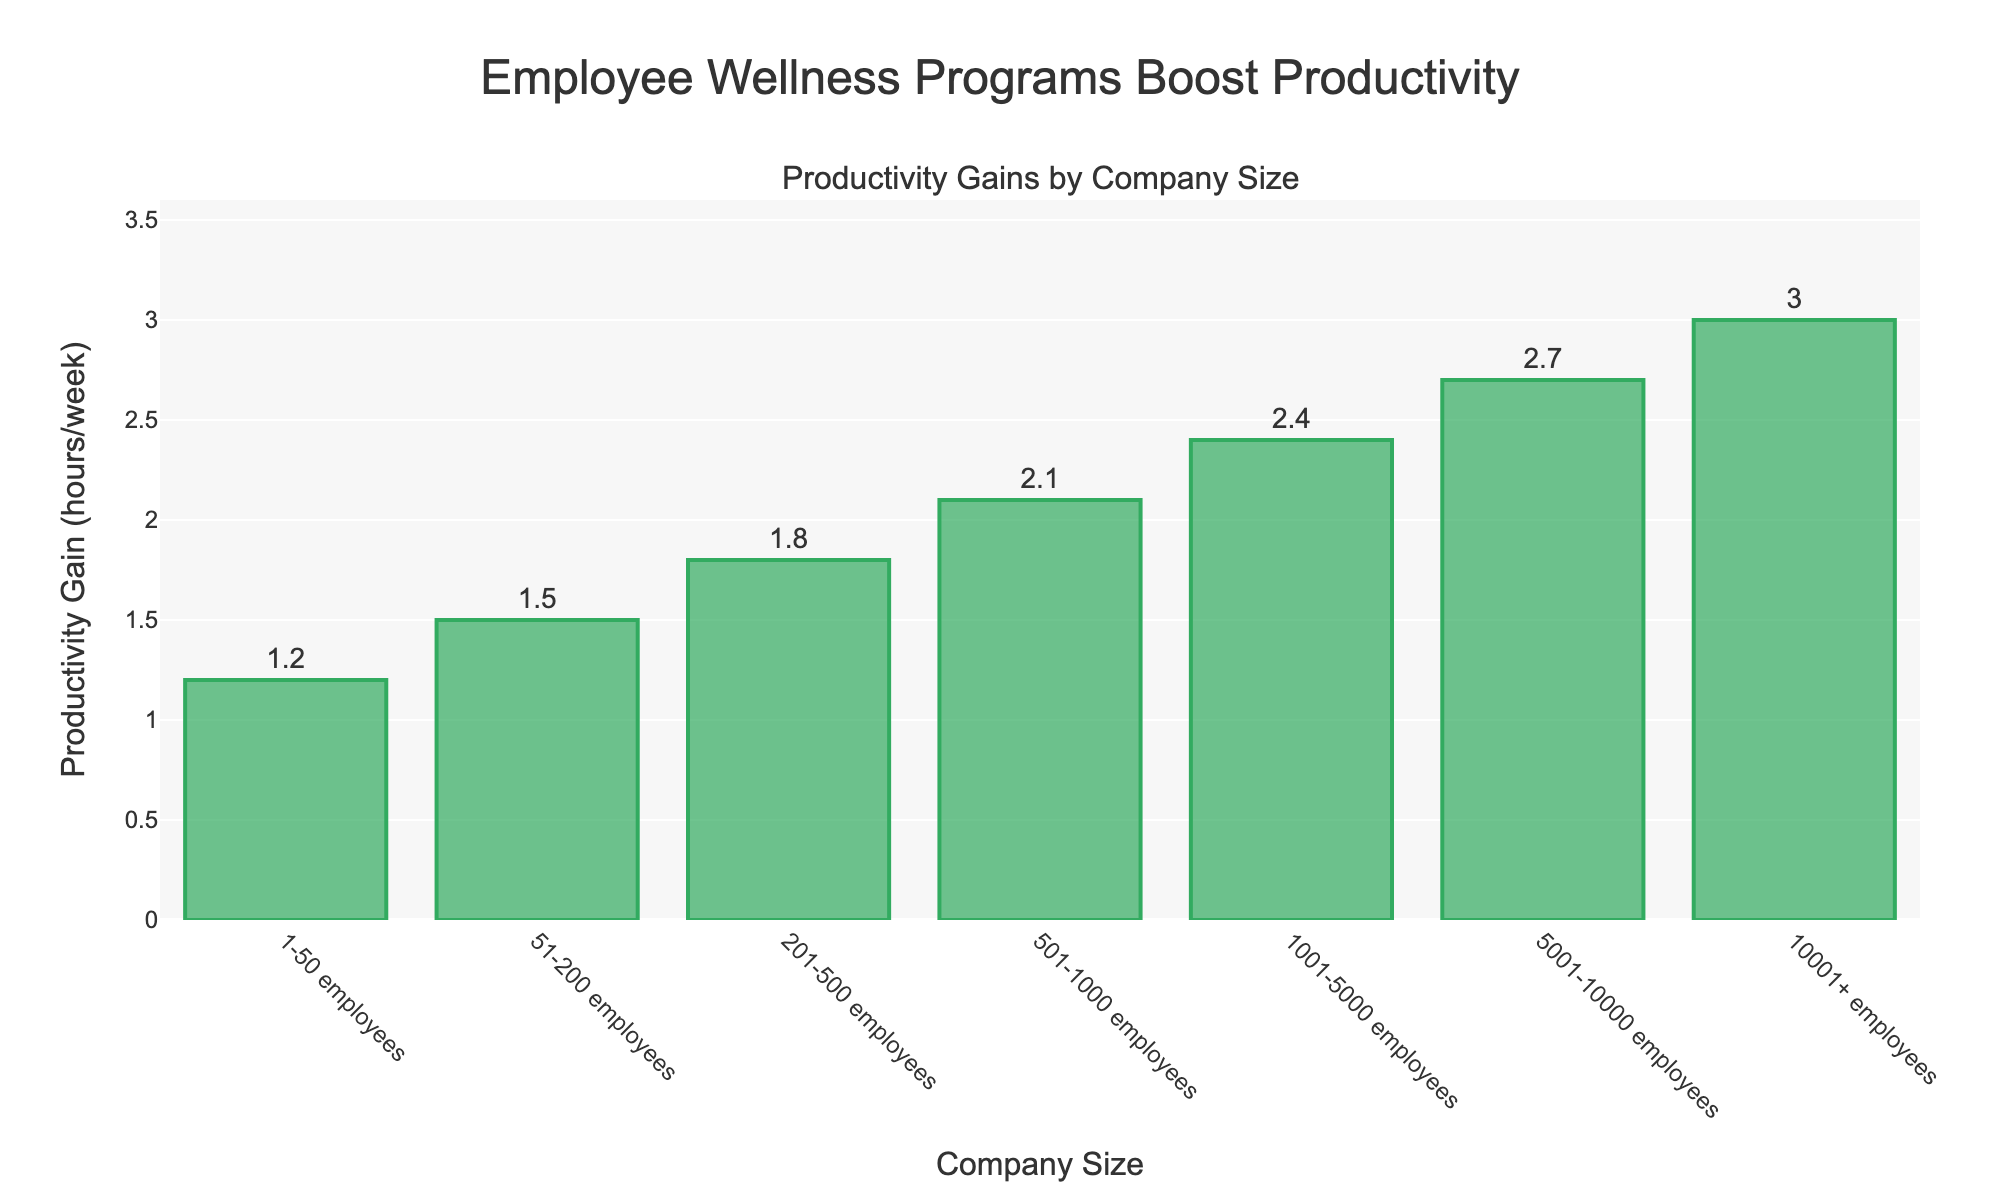What is the productivity gain for companies with 1-50 employees? The bar representing companies with 1-50 employees shows a productivity gain of 1.2 hours per week, indicated by the height of the bar and the text label atop it.
Answer: 1.2 How does the productivity gain for companies with 10001+ employees compare to that of companies with 1-50 employees? The bar for 10001+ employees reaches 3.0 hours per week, while the bar for 1-50 employees is at 1.2 hours per week. Subtracting 1.2 from 3.0 gives the difference.
Answer: 1.8 Which company size category sees the highest productivity gain from wellness programs? The bar for 10001+ employees is the tallest among the categories, reaching 3.0 hours per week.
Answer: 10001+ employees What is the total productivity gain for companies with 51-200 employees and 201-500 employees combined? Add the productivity gains for 51-200 employees (1.5 hours) and 201-500 employees (1.8 hours). 1.5 + 1.8 = 3.3 hours.
Answer: 3.3 Is the productivity gain for companies with 501-1000 employees greater than 2 hours per week? The bar representing 501-1000 employees shows a productivity gain of 2.1 hours per week, indicated by its height and the text label.
Answer: Yes What is the difference in productivity gain between companies with 501-1000 employees and companies with 201-500 employees? Subtract the productivity gain for 201-500 employees (1.8 hours) from the gain for 501-1000 employees (2.1 hours). 2.1 - 1.8 = 0.3 hours.
Answer: 0.3 How much more productivity gain do companies with 5001-10000 employees have compared to companies with 51-200 employees? Subtract the productivity gain for 51-200 employees (1.5 hours) from the gain for 5001-10000 employees (2.7 hours). 2.7 - 1.5 = 1.2 hours.
Answer: 1.2 What is the average productivity gain for companies with 1-50 employees, 51-200 employees, and 201-500 employees? Add the productivity gains for 1-50 (1.2), 51-200 (1.5), and 201-500 (1.8) employees, then divide by the number of categories (3). (1.2 + 1.5 + 1.8) / 3 = 4.5 / 3 = 1.5 hours.
Answer: 1.5 Which company size category has a productivity gain of more than 2 hours per week but less than 3 hours per week? The bars for 501-1000 (2.1), 1001-5000 (2.4), and 5001-10000 (2.7) employees show productivity gains in this range.
Answer: 501-1000, 1001-5000, 5001-10000 